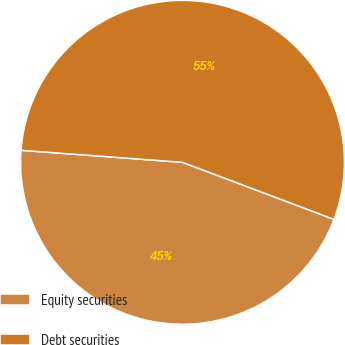Convert chart. <chart><loc_0><loc_0><loc_500><loc_500><pie_chart><fcel>Equity securities<fcel>Debt securities<nl><fcel>45.45%<fcel>54.55%<nl></chart> 